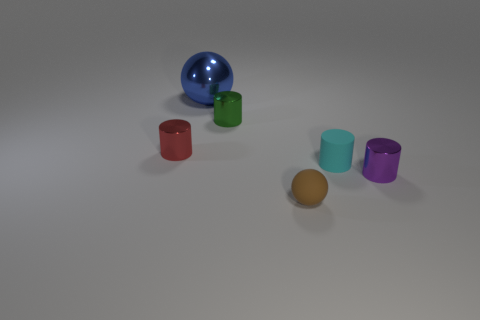Is the number of big metal objects less than the number of big green metallic things?
Provide a succinct answer. No. How many small purple objects have the same shape as the blue metallic thing?
Make the answer very short. 0. What is the color of the rubber sphere that is the same size as the green object?
Offer a terse response. Brown. Are there the same number of small cyan objects that are left of the red cylinder and small rubber things that are to the left of the green metallic thing?
Offer a terse response. Yes. Are there any brown rubber things that have the same size as the green metallic object?
Make the answer very short. Yes. How big is the blue object?
Your answer should be very brief. Large. Is the number of small purple things that are right of the cyan rubber cylinder the same as the number of tiny blue metal balls?
Ensure brevity in your answer.  No. What color is the object that is behind the red object and in front of the metal ball?
Your answer should be very brief. Green. What size is the sphere in front of the cylinder to the left of the small cylinder that is behind the tiny red cylinder?
Keep it short and to the point. Small. What number of things are either small things that are in front of the small purple metal cylinder or metallic cylinders that are on the left side of the brown sphere?
Your answer should be compact. 3. 